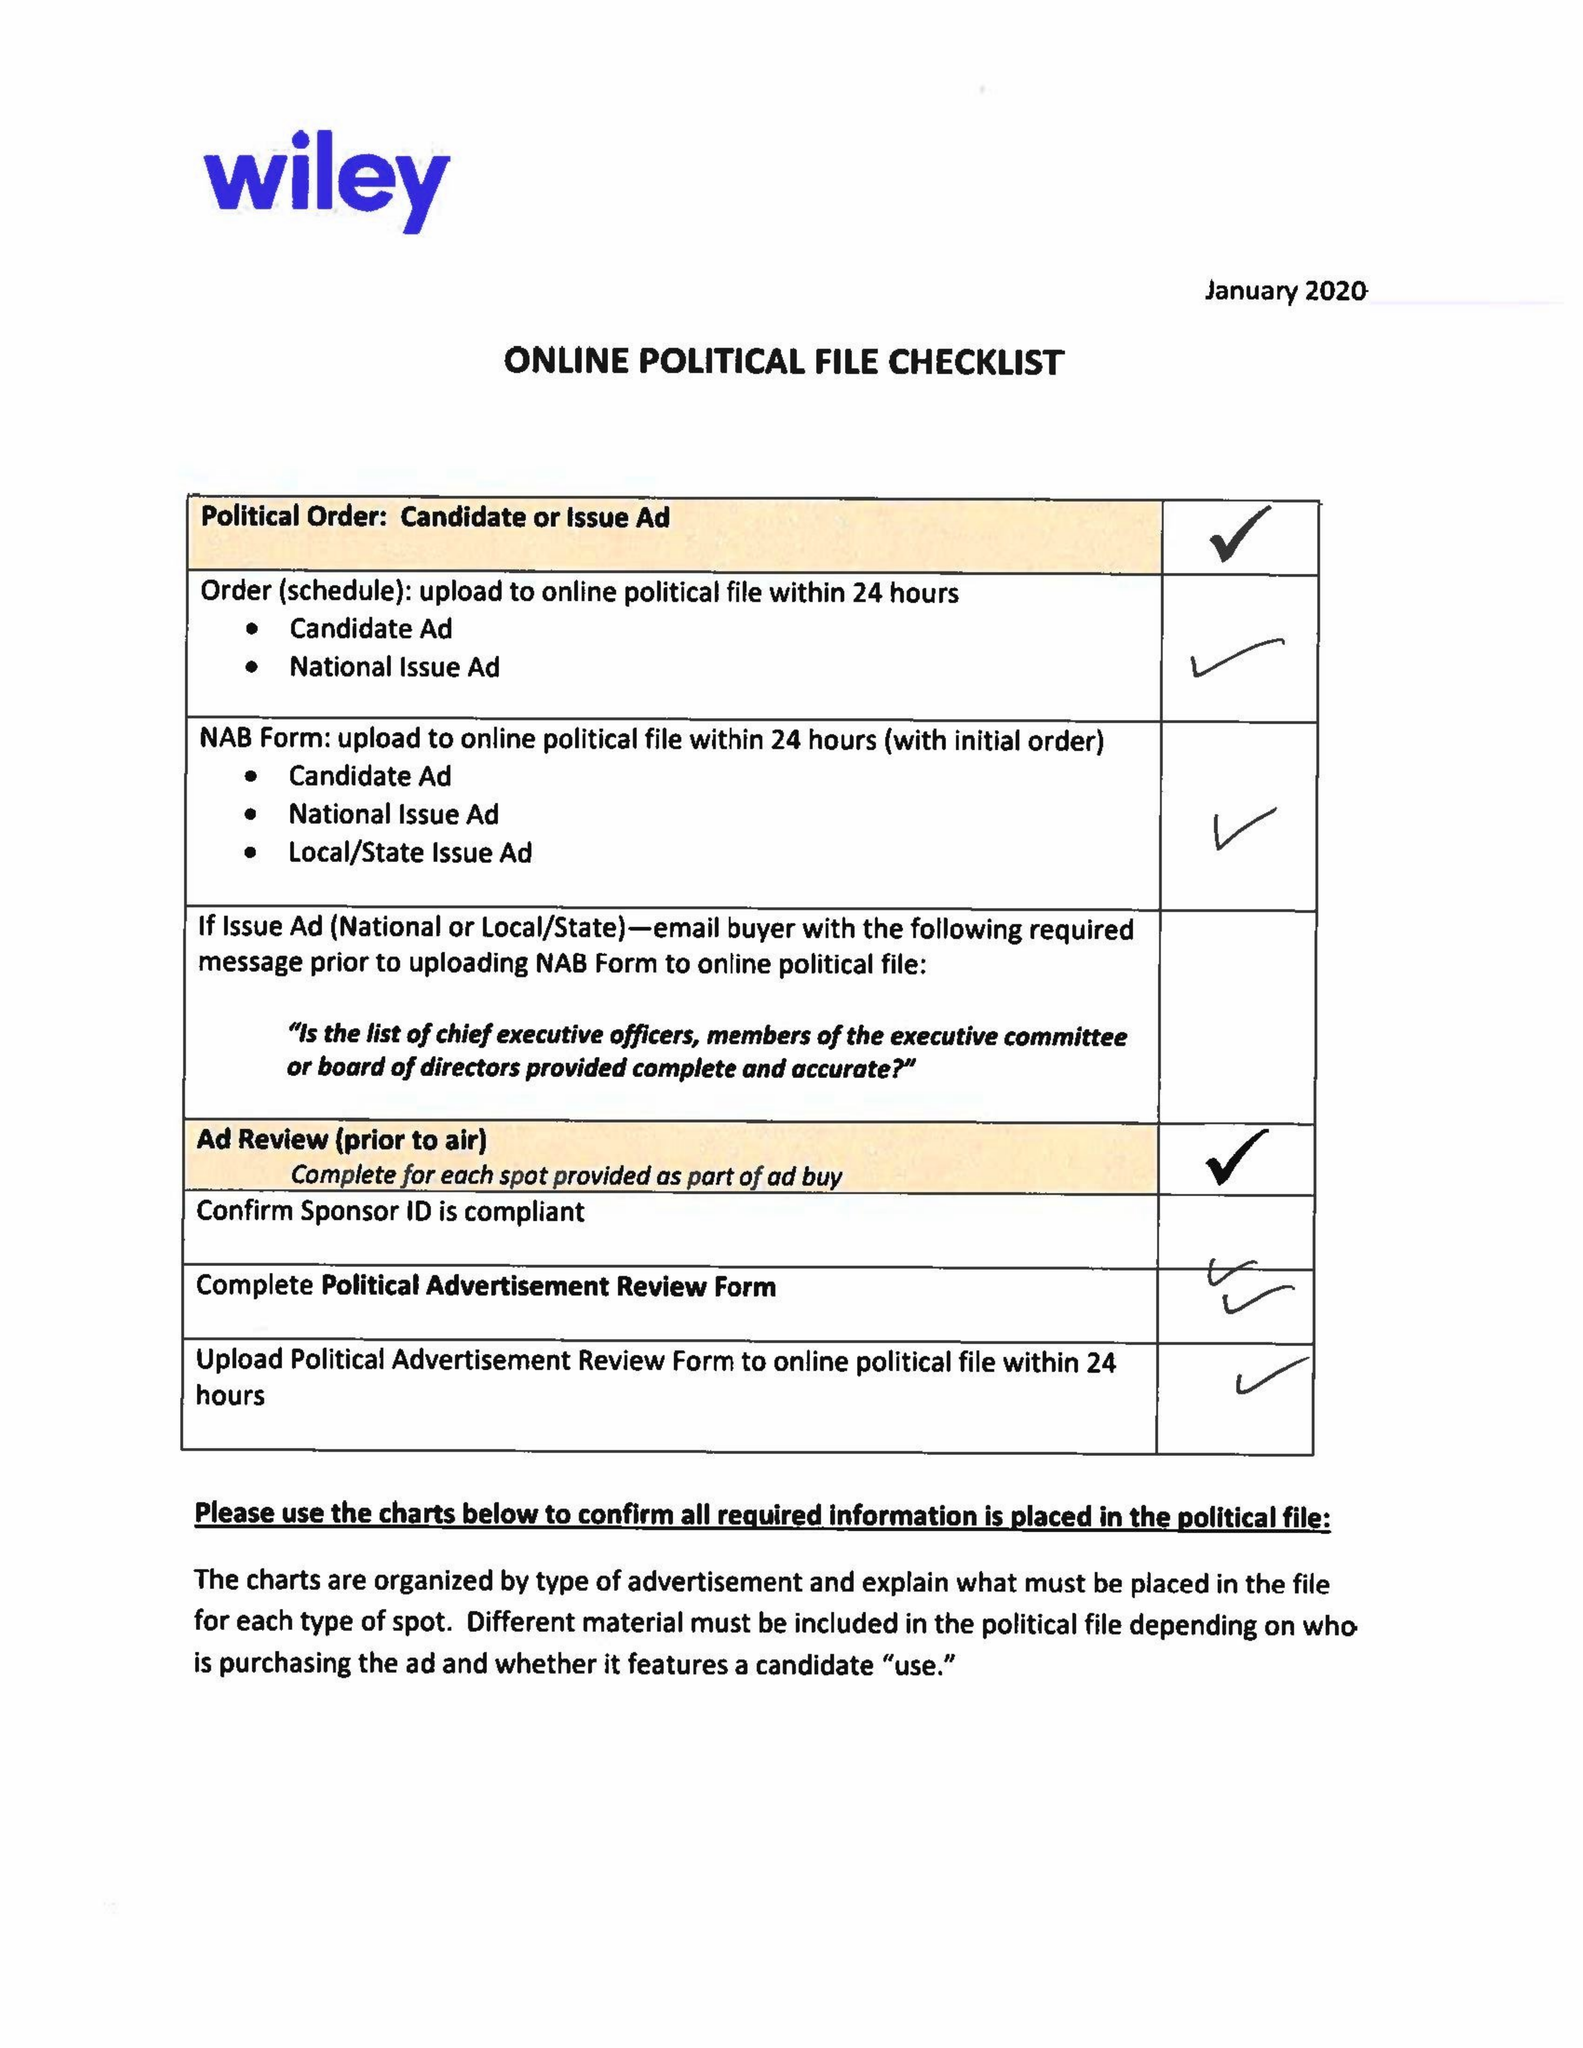What is the value for the advertiser?
Answer the question using a single word or phrase. BRADLEY BYRNE FOR US SENATE 